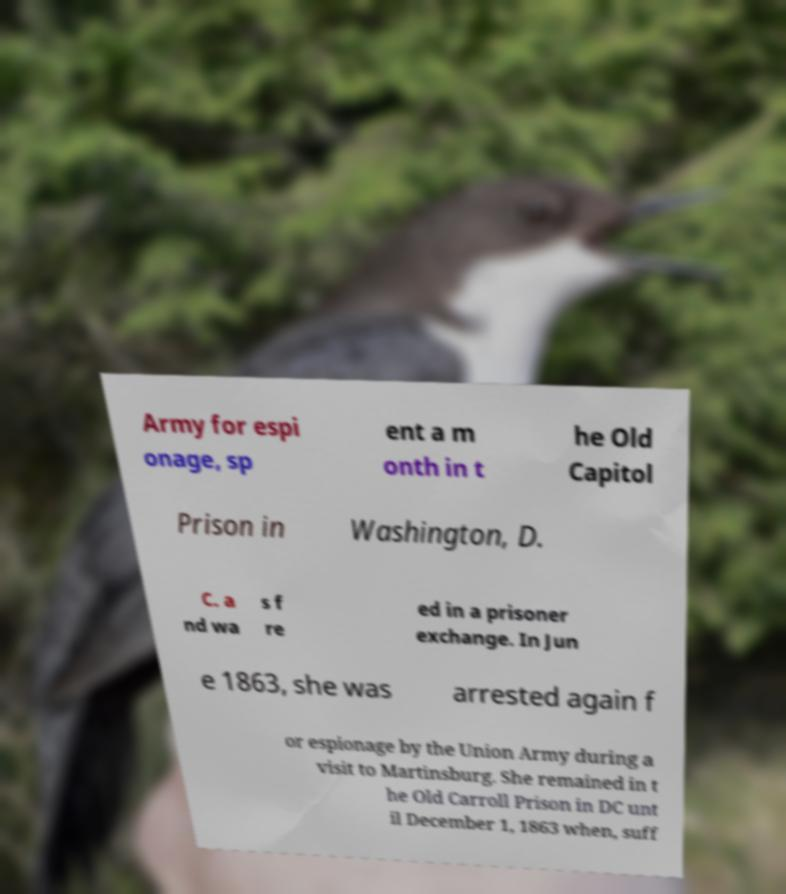Could you extract and type out the text from this image? Army for espi onage, sp ent a m onth in t he Old Capitol Prison in Washington, D. C. a nd wa s f re ed in a prisoner exchange. In Jun e 1863, she was arrested again f or espionage by the Union Army during a visit to Martinsburg. She remained in t he Old Carroll Prison in DC unt il December 1, 1863 when, suff 